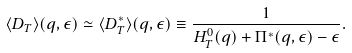Convert formula to latex. <formula><loc_0><loc_0><loc_500><loc_500>\langle { D } _ { T } \rangle ( { q } , \epsilon ) \simeq \langle { D } _ { T } ^ { * } \rangle ( { q } , \epsilon ) \equiv \frac { 1 } { H ^ { 0 } _ { T } ( q ) + \Pi ^ { * } ( { q } , \epsilon ) - \epsilon } .</formula> 